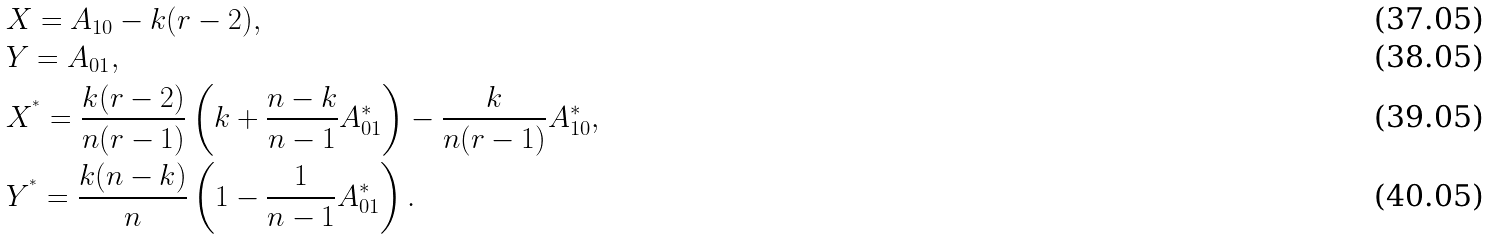<formula> <loc_0><loc_0><loc_500><loc_500>& X = A _ { 1 0 } - k ( r - 2 ) , \\ & Y = A _ { 0 1 } , \\ & X ^ { ^ { * } } = \frac { k ( r - 2 ) } { n ( r - 1 ) } \left ( k + \frac { n - k } { n - 1 } A ^ { * } _ { 0 1 } \right ) - \frac { k } { n ( r - 1 ) } A ^ { * } _ { 1 0 } , \\ & Y ^ { ^ { * } } = \frac { k ( n - k ) } { n } \left ( 1 - \frac { 1 } { n - 1 } A ^ { * } _ { 0 1 } \right ) .</formula> 